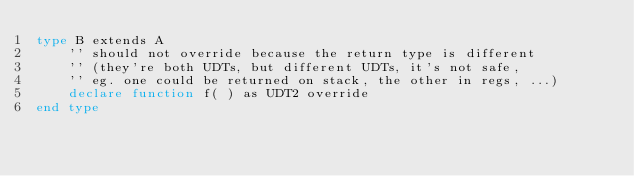Convert code to text. <code><loc_0><loc_0><loc_500><loc_500><_VisualBasic_>type B extends A
	'' should not override because the return type is different
	'' (they're both UDTs, but different UDTs, it's not safe,
	'' eg. one could be returned on stack, the other in regs, ...)
	declare function f( ) as UDT2 override
end type
</code> 